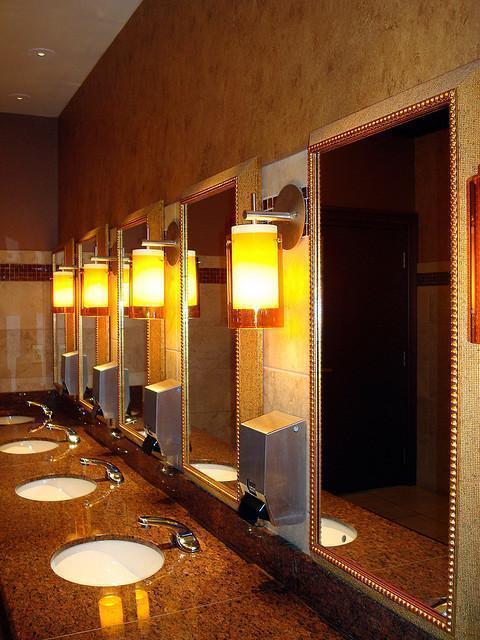What are the metal boxes on the wall used for?
Make your selection from the four choices given to correctly answer the question.
Options: Towels, hot water, soap dispenser, dry hands. Soap dispenser. 